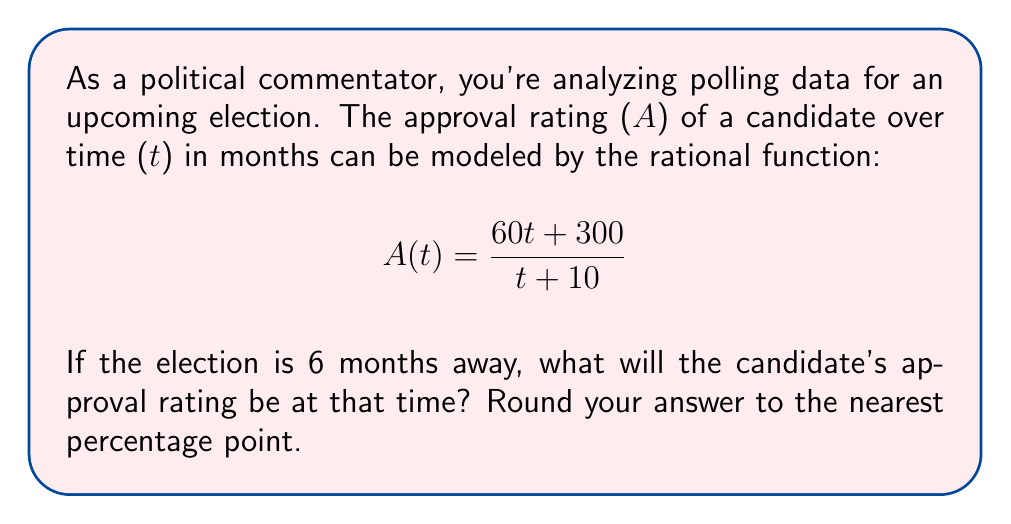Teach me how to tackle this problem. To solve this problem, we'll follow these steps:

1) We're given the rational function for approval rating:
   $$A(t) = \frac{60t + 300}{t + 10}$$

2) We need to find A(6) since the election is 6 months away:
   $$A(6) = \frac{60(6) + 300}{6 + 10}$$

3) Let's simplify the numerator:
   $$A(6) = \frac{360 + 300}{16} = \frac{660}{16}$$

4) Now, let's divide:
   $$A(6) = 41.25$$

5) Rounding to the nearest percentage point:
   41.25% ≈ 41%

Therefore, the candidate's approval rating 6 months before the election will be approximately 41%.
Answer: 41% 